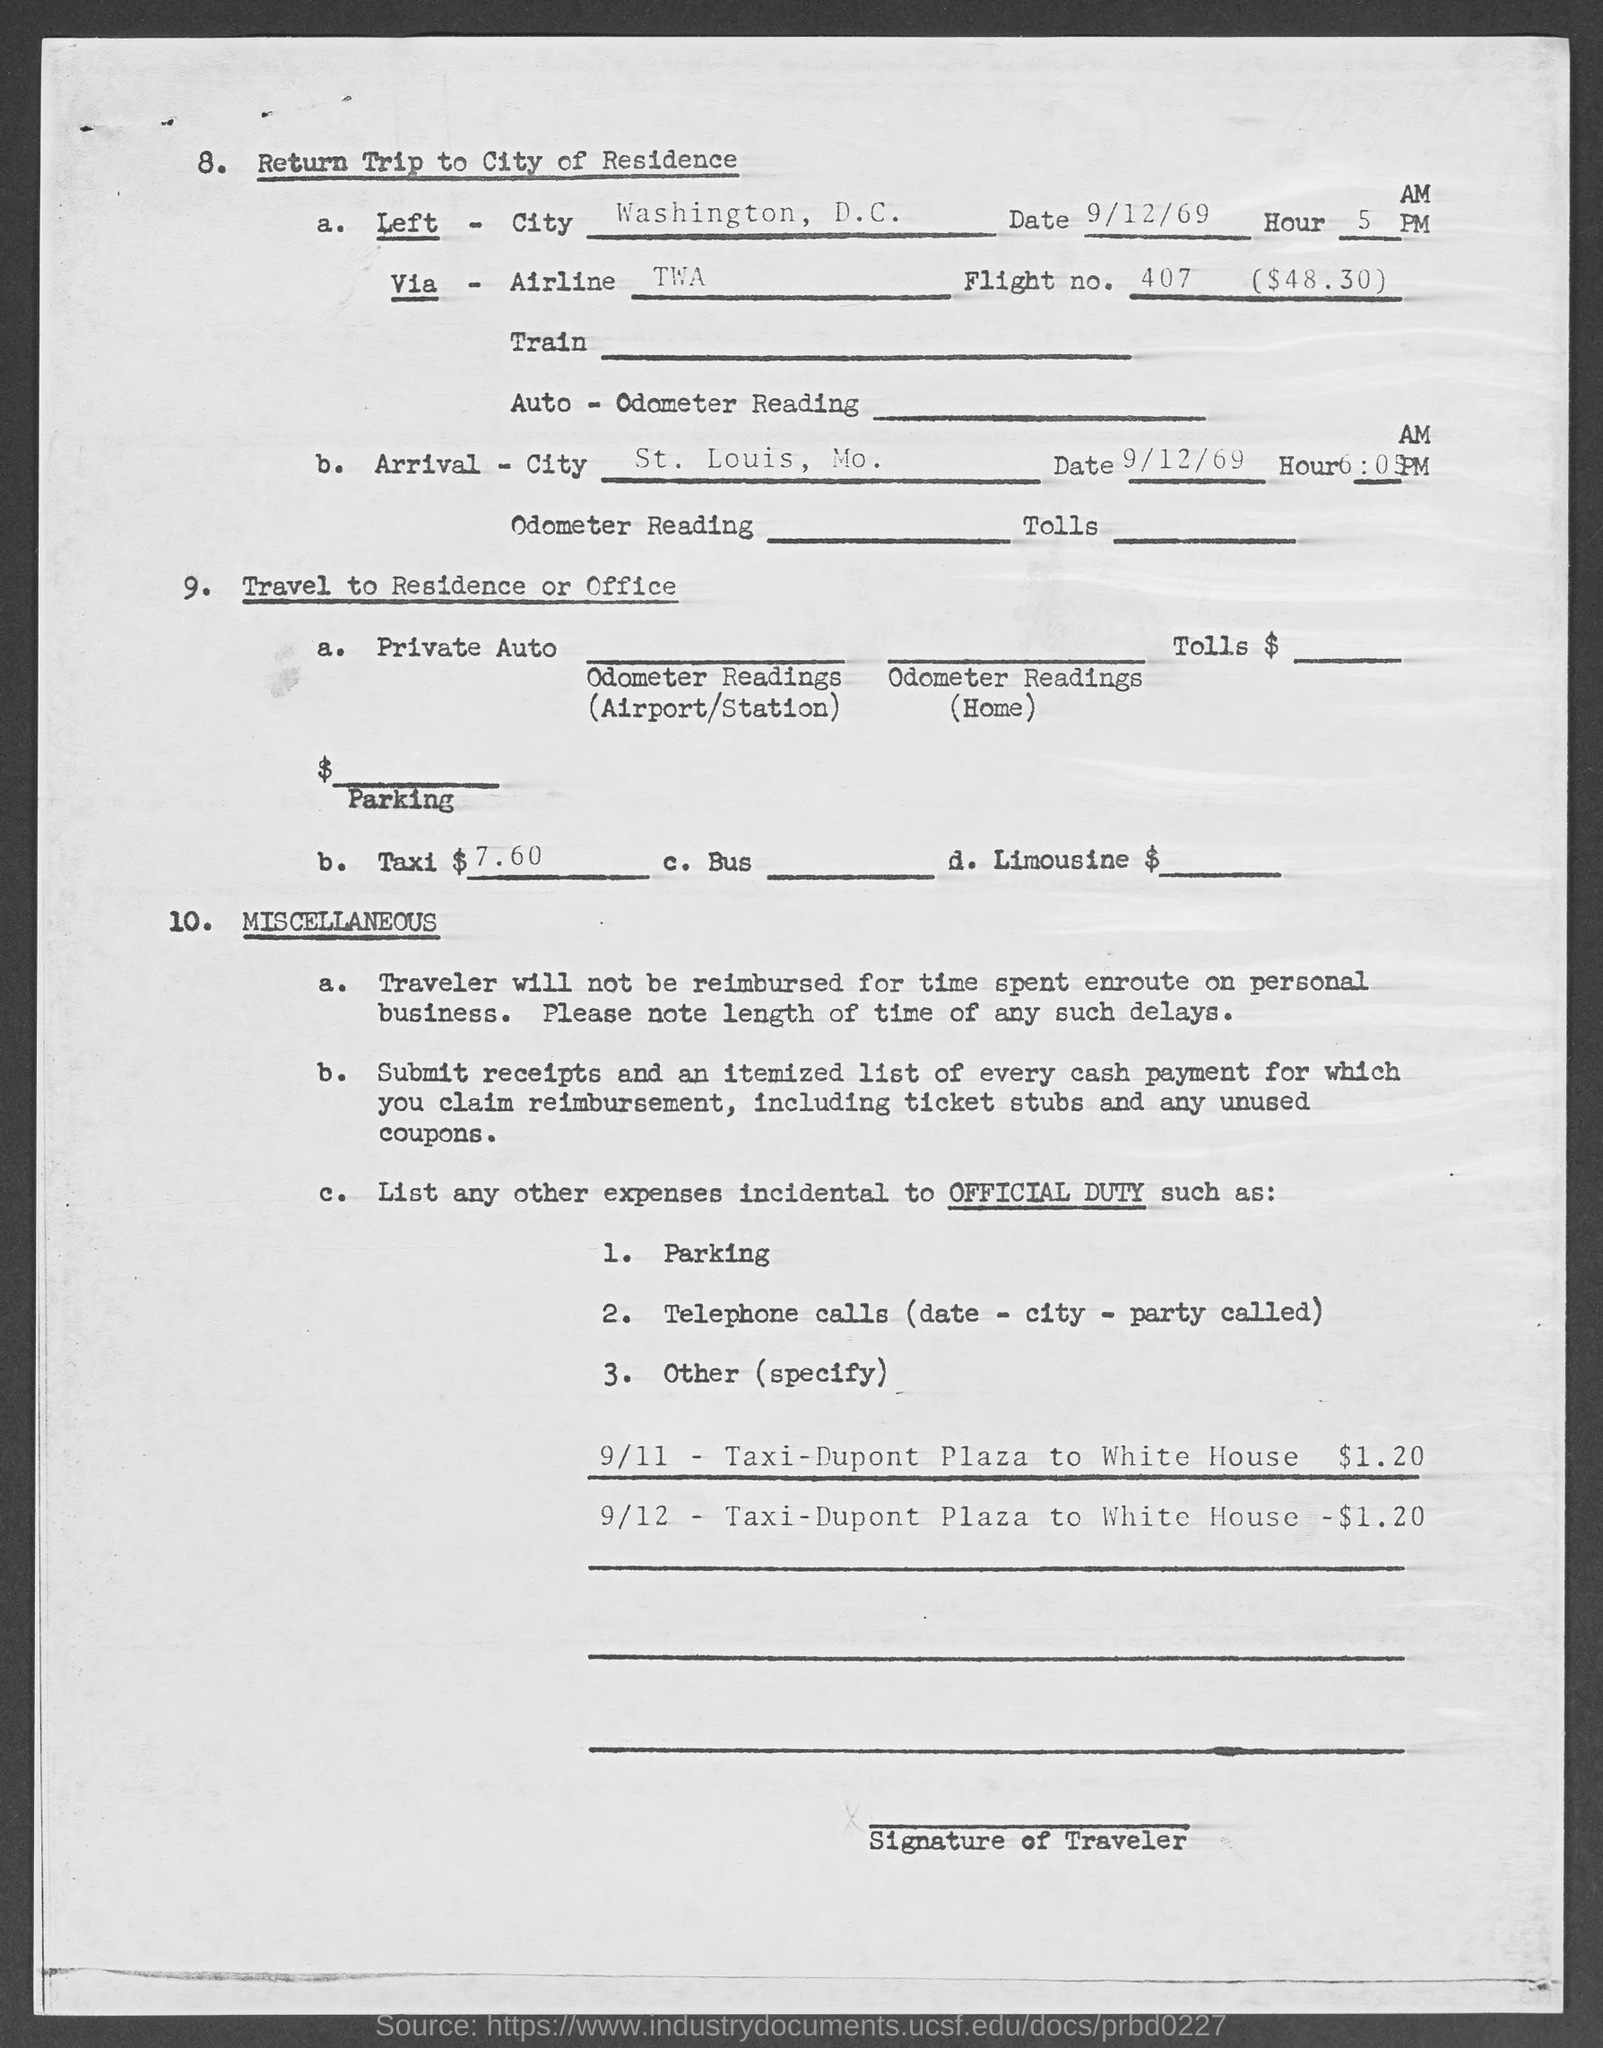What is the date of left mentioned in the given page ?
Your answer should be compact. 9/12/69. What is the name of the left city mentioned in the given page ?
Make the answer very short. Washington, d.c. What is the date of arrival  mentioned in the given page ?
Provide a succinct answer. 9/12/69. What is the arrival city mentioned in the given page ?
Provide a short and direct response. St. louis, mo. What is the flight no. mentioned in the given page ?
Ensure brevity in your answer.  407  ($48.30). What is the cost of the taxi mentioned in the given page ?
Give a very brief answer. $ 7.60. 